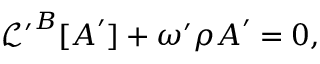<formula> <loc_0><loc_0><loc_500><loc_500>\begin{array} { r } { \mathcal { L } ^ { \prime } ^ { B } [ A ^ { \prime } ] + \omega ^ { \prime } \rho A ^ { \prime } = 0 , } \end{array}</formula> 